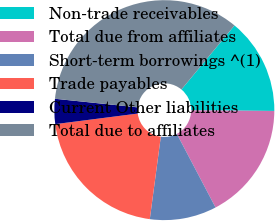<chart> <loc_0><loc_0><loc_500><loc_500><pie_chart><fcel>Non-trade receivables<fcel>Total due from affiliates<fcel>Short-term borrowings ^(1)<fcel>Trade payables<fcel>Current Other liabilities<fcel>Total due to affiliates<nl><fcel>14.11%<fcel>17.18%<fcel>9.82%<fcel>20.86%<fcel>3.68%<fcel>34.36%<nl></chart> 